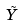<formula> <loc_0><loc_0><loc_500><loc_500>\tilde { Y }</formula> 